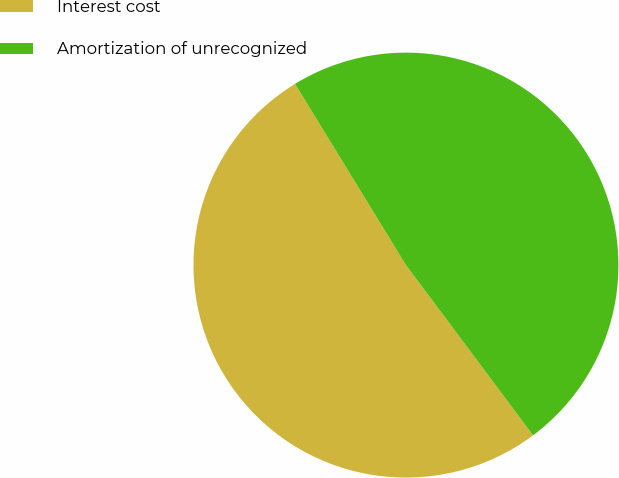<chart> <loc_0><loc_0><loc_500><loc_500><pie_chart><fcel>Interest cost<fcel>Amortization of unrecognized<nl><fcel>51.46%<fcel>48.54%<nl></chart> 